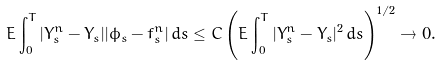<formula> <loc_0><loc_0><loc_500><loc_500>E \int _ { 0 } ^ { T } | Y ^ { n } _ { s } - Y _ { s } | | \phi _ { s } - f _ { s } ^ { n } | \, d s \leq C \left ( E \int _ { 0 } ^ { T } | Y ^ { n } _ { s } - Y _ { s } | ^ { 2 } \, d s \right ) ^ { 1 / 2 } \rightarrow 0 .</formula> 